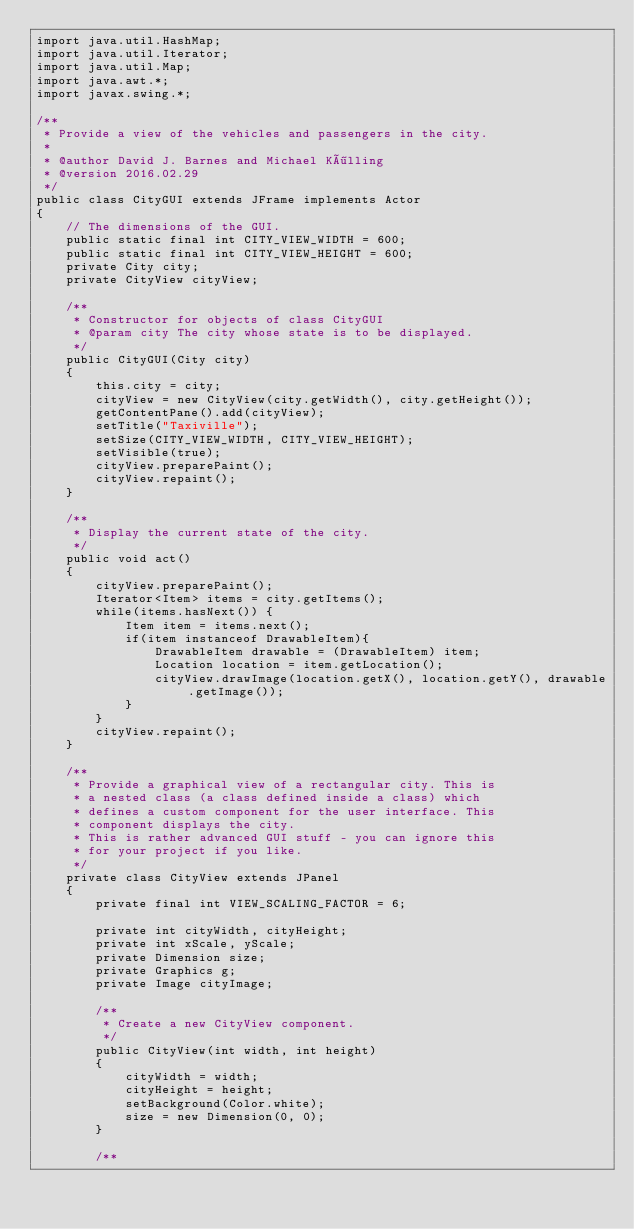<code> <loc_0><loc_0><loc_500><loc_500><_Java_>import java.util.HashMap;
import java.util.Iterator;
import java.util.Map;
import java.awt.*;
import javax.swing.*;
    
/**
 * Provide a view of the vehicles and passengers in the city.
 * 
 * @author David J. Barnes and Michael Kölling
 * @version 2016.02.29
 */
public class CityGUI extends JFrame implements Actor
{
    // The dimensions of the GUI.
    public static final int CITY_VIEW_WIDTH = 600;
    public static final int CITY_VIEW_HEIGHT = 600;
    private City city;
    private CityView cityView;
    
    /**
     * Constructor for objects of class CityGUI
     * @param city The city whose state is to be displayed.
     */
    public CityGUI(City city)
    {
        this.city = city;
        cityView = new CityView(city.getWidth(), city.getHeight());
        getContentPane().add(cityView);
        setTitle("Taxiville");
        setSize(CITY_VIEW_WIDTH, CITY_VIEW_HEIGHT);
        setVisible(true);
        cityView.preparePaint();
        cityView.repaint();    
    }
    
    /**
     * Display the current state of the city.
     */
    public void act()
    {
        cityView.preparePaint();
        Iterator<Item> items = city.getItems();
        while(items.hasNext()) {
            Item item = items.next();
            if(item instanceof DrawableItem){
                DrawableItem drawable = (DrawableItem) item;
                Location location = item.getLocation();
                cityView.drawImage(location.getX(), location.getY(), drawable.getImage());
            }
        }
        cityView.repaint();    
    }
    
    /**
     * Provide a graphical view of a rectangular city. This is 
     * a nested class (a class defined inside a class) which
     * defines a custom component for the user interface. This
     * component displays the city.
     * This is rather advanced GUI stuff - you can ignore this 
     * for your project if you like.
     */
    private class CityView extends JPanel
    {
        private final int VIEW_SCALING_FACTOR = 6;

        private int cityWidth, cityHeight;
        private int xScale, yScale;
        private Dimension size;
        private Graphics g;
        private Image cityImage;

        /**
         * Create a new CityView component.
         */
        public CityView(int width, int height)
        {
            cityWidth = width;
            cityHeight = height;
            setBackground(Color.white);
            size = new Dimension(0, 0);
        }

        /**</code> 